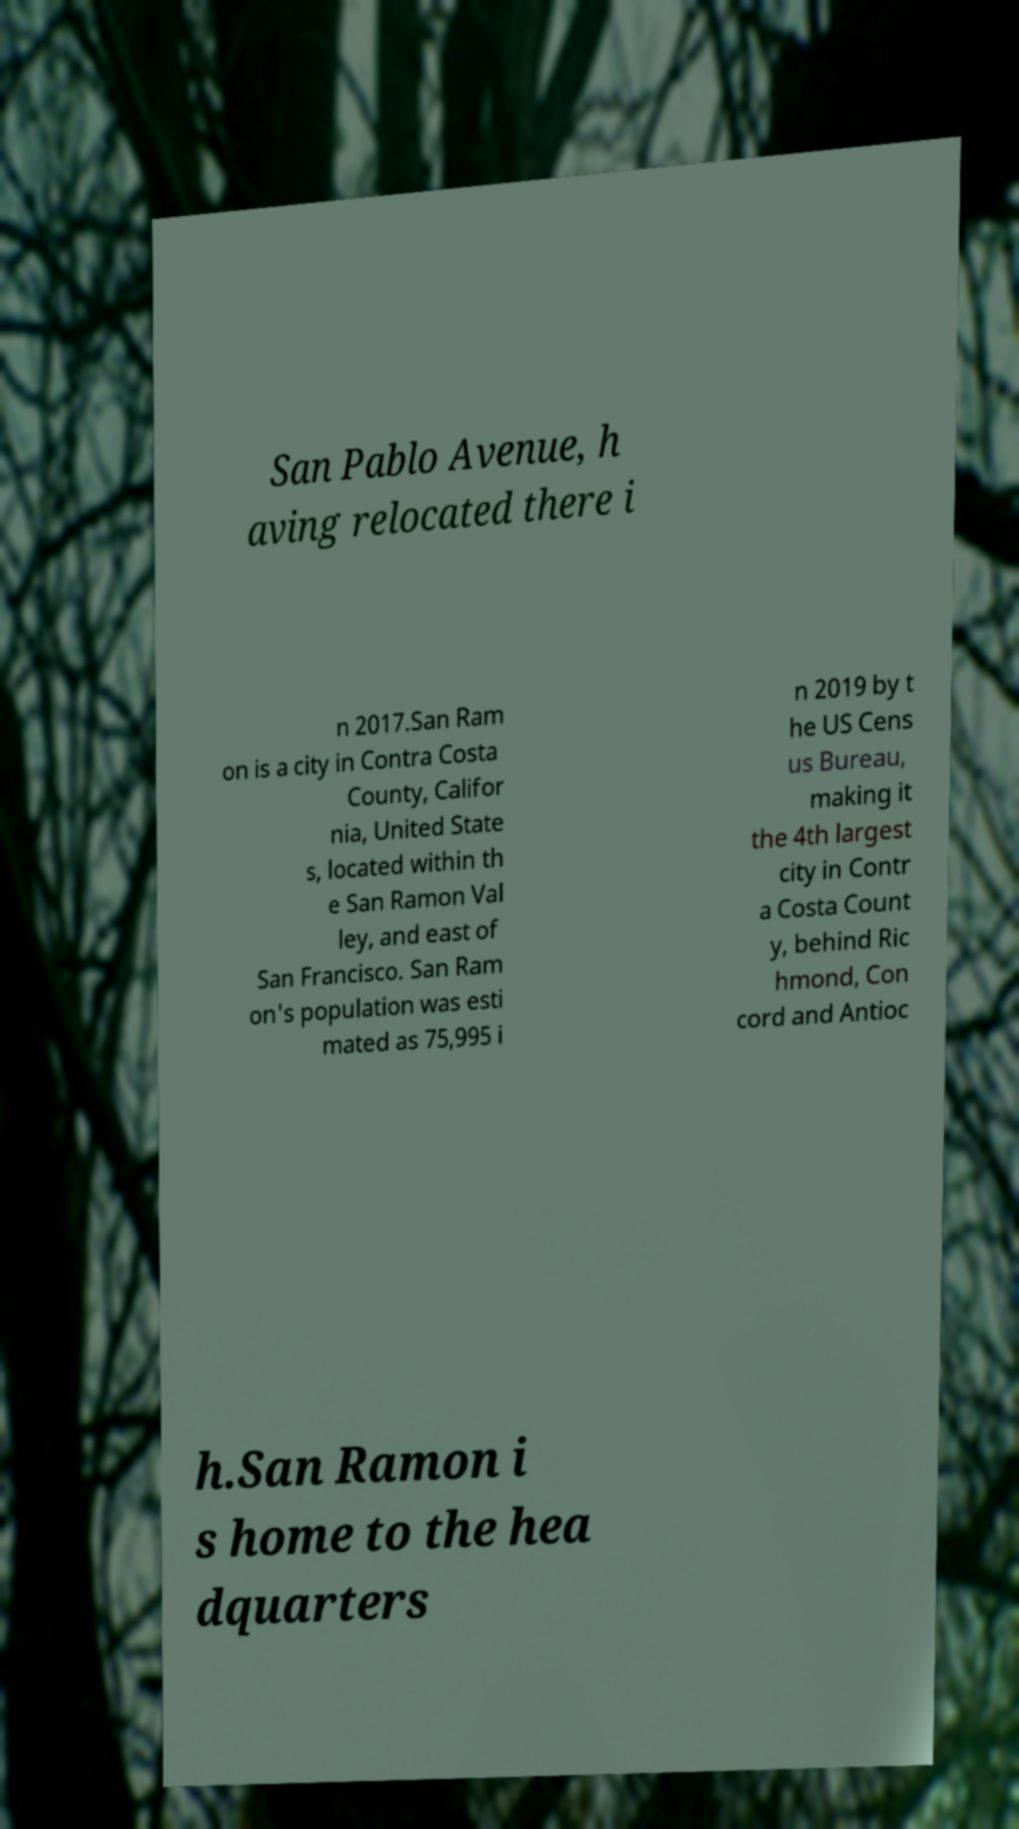Could you assist in decoding the text presented in this image and type it out clearly? San Pablo Avenue, h aving relocated there i n 2017.San Ram on is a city in Contra Costa County, Califor nia, United State s, located within th e San Ramon Val ley, and east of San Francisco. San Ram on's population was esti mated as 75,995 i n 2019 by t he US Cens us Bureau, making it the 4th largest city in Contr a Costa Count y, behind Ric hmond, Con cord and Antioc h.San Ramon i s home to the hea dquarters 